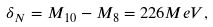Convert formula to latex. <formula><loc_0><loc_0><loc_500><loc_500>\delta _ { N } = M _ { 1 0 } - M _ { 8 } = 2 2 6 M e V ,</formula> 